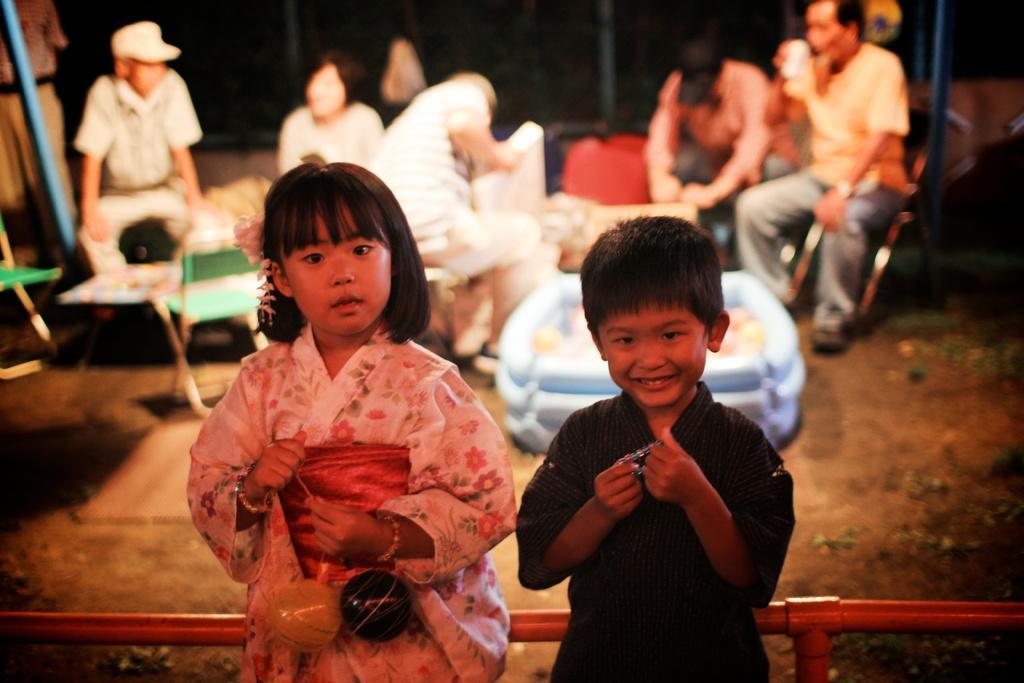How would you summarize this image in a sentence or two? There are two children in different color dresses, holding some objects, smiling and standing near a fencing. In the background, there are other persons who are sitting and there are chairs. And the background is dark in color. 